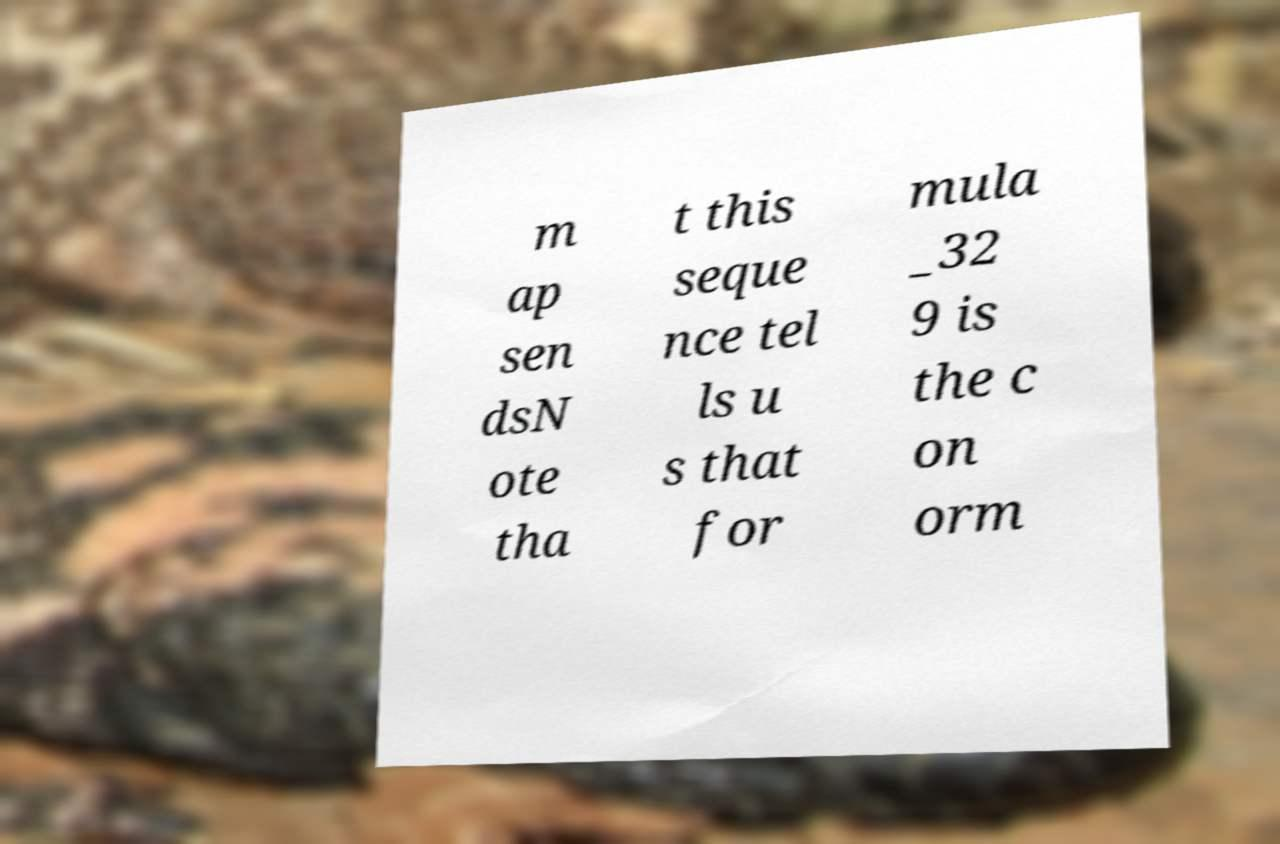Could you extract and type out the text from this image? m ap sen dsN ote tha t this seque nce tel ls u s that for mula _32 9 is the c on orm 